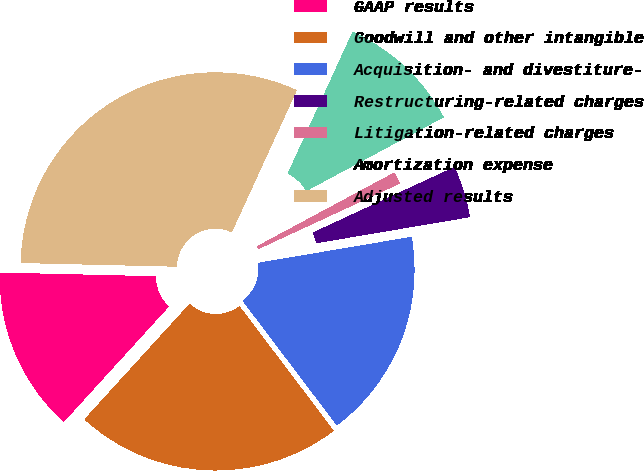<chart> <loc_0><loc_0><loc_500><loc_500><pie_chart><fcel>GAAP results<fcel>Goodwill and other intangible<fcel>Acquisition- and divestiture-<fcel>Restructuring-related charges<fcel>Litigation-related charges<fcel>Amortization expense<fcel>Adjusted results<nl><fcel>13.62%<fcel>22.07%<fcel>17.37%<fcel>4.23%<fcel>0.94%<fcel>10.33%<fcel>31.46%<nl></chart> 